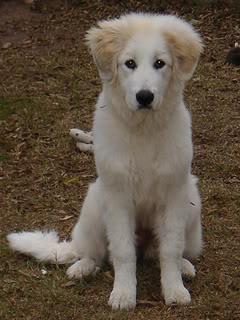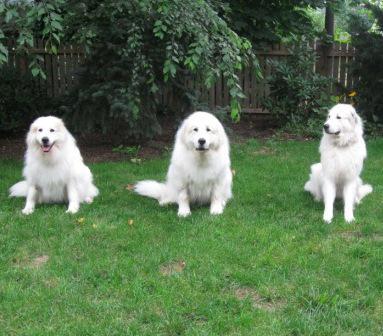The first image is the image on the left, the second image is the image on the right. For the images displayed, is the sentence "One of the images features a single dog laying on grass." factually correct? Answer yes or no. No. The first image is the image on the left, the second image is the image on the right. Evaluate the accuracy of this statement regarding the images: "A white dog is lying on green grass in both images.". Is it true? Answer yes or no. No. 